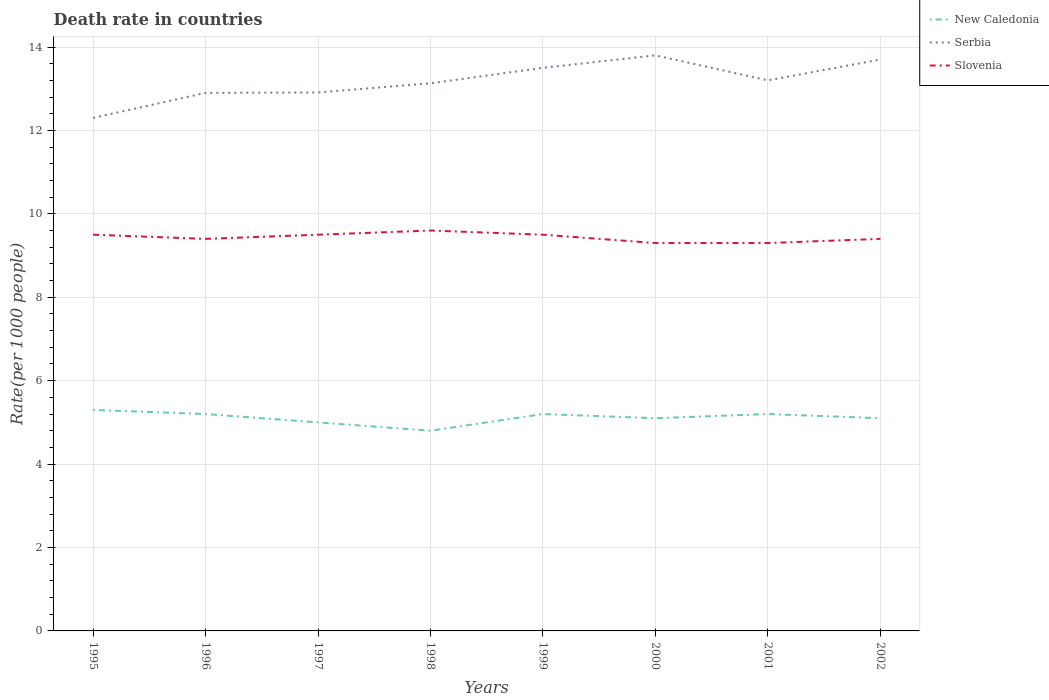How many different coloured lines are there?
Keep it short and to the point. 3. Does the line corresponding to Serbia intersect with the line corresponding to New Caledonia?
Provide a succinct answer. No. In which year was the death rate in New Caledonia maximum?
Your response must be concise. 1998. What is the total death rate in Serbia in the graph?
Give a very brief answer. 0.1. What is the difference between the highest and the second highest death rate in Slovenia?
Your response must be concise. 0.3. How many legend labels are there?
Give a very brief answer. 3. How are the legend labels stacked?
Your answer should be compact. Vertical. What is the title of the graph?
Your answer should be very brief. Death rate in countries. What is the label or title of the Y-axis?
Your response must be concise. Rate(per 1000 people). What is the Rate(per 1000 people) in Slovenia in 1995?
Keep it short and to the point. 9.5. What is the Rate(per 1000 people) in Serbia in 1996?
Offer a very short reply. 12.9. What is the Rate(per 1000 people) of Slovenia in 1996?
Give a very brief answer. 9.4. What is the Rate(per 1000 people) of New Caledonia in 1997?
Give a very brief answer. 5. What is the Rate(per 1000 people) of Serbia in 1997?
Ensure brevity in your answer.  12.91. What is the Rate(per 1000 people) in Slovenia in 1997?
Keep it short and to the point. 9.5. What is the Rate(per 1000 people) in New Caledonia in 1998?
Give a very brief answer. 4.8. What is the Rate(per 1000 people) in Serbia in 1998?
Your response must be concise. 13.13. What is the Rate(per 1000 people) of New Caledonia in 2000?
Offer a terse response. 5.1. What is the Rate(per 1000 people) of Slovenia in 2000?
Ensure brevity in your answer.  9.3. What is the Rate(per 1000 people) of Slovenia in 2001?
Offer a terse response. 9.3. What is the Rate(per 1000 people) in Serbia in 2002?
Your response must be concise. 13.7. Across all years, what is the maximum Rate(per 1000 people) of New Caledonia?
Your answer should be compact. 5.3. Across all years, what is the maximum Rate(per 1000 people) of Serbia?
Ensure brevity in your answer.  13.8. Across all years, what is the maximum Rate(per 1000 people) of Slovenia?
Keep it short and to the point. 9.6. Across all years, what is the minimum Rate(per 1000 people) in Serbia?
Your answer should be compact. 12.3. What is the total Rate(per 1000 people) of New Caledonia in the graph?
Offer a terse response. 40.9. What is the total Rate(per 1000 people) in Serbia in the graph?
Your answer should be very brief. 105.44. What is the total Rate(per 1000 people) of Slovenia in the graph?
Give a very brief answer. 75.5. What is the difference between the Rate(per 1000 people) of Slovenia in 1995 and that in 1996?
Your answer should be compact. 0.1. What is the difference between the Rate(per 1000 people) in Serbia in 1995 and that in 1997?
Give a very brief answer. -0.61. What is the difference between the Rate(per 1000 people) in Slovenia in 1995 and that in 1997?
Give a very brief answer. 0. What is the difference between the Rate(per 1000 people) of New Caledonia in 1995 and that in 1998?
Provide a short and direct response. 0.5. What is the difference between the Rate(per 1000 people) of Serbia in 1995 and that in 1998?
Provide a short and direct response. -0.83. What is the difference between the Rate(per 1000 people) of Slovenia in 1995 and that in 1998?
Give a very brief answer. -0.1. What is the difference between the Rate(per 1000 people) of New Caledonia in 1995 and that in 1999?
Provide a succinct answer. 0.1. What is the difference between the Rate(per 1000 people) in Serbia in 1995 and that in 1999?
Give a very brief answer. -1.2. What is the difference between the Rate(per 1000 people) in New Caledonia in 1995 and that in 2001?
Offer a terse response. 0.1. What is the difference between the Rate(per 1000 people) of New Caledonia in 1995 and that in 2002?
Your answer should be compact. 0.2. What is the difference between the Rate(per 1000 people) in Slovenia in 1995 and that in 2002?
Your response must be concise. 0.1. What is the difference between the Rate(per 1000 people) in Serbia in 1996 and that in 1997?
Your answer should be very brief. -0.01. What is the difference between the Rate(per 1000 people) of New Caledonia in 1996 and that in 1998?
Your response must be concise. 0.4. What is the difference between the Rate(per 1000 people) of Serbia in 1996 and that in 1998?
Ensure brevity in your answer.  -0.23. What is the difference between the Rate(per 1000 people) of Slovenia in 1996 and that in 1999?
Ensure brevity in your answer.  -0.1. What is the difference between the Rate(per 1000 people) of Serbia in 1996 and that in 2000?
Offer a very short reply. -0.9. What is the difference between the Rate(per 1000 people) in New Caledonia in 1996 and that in 2002?
Offer a terse response. 0.1. What is the difference between the Rate(per 1000 people) of Slovenia in 1996 and that in 2002?
Your answer should be compact. 0. What is the difference between the Rate(per 1000 people) of Serbia in 1997 and that in 1998?
Offer a very short reply. -0.22. What is the difference between the Rate(per 1000 people) of Slovenia in 1997 and that in 1998?
Offer a terse response. -0.1. What is the difference between the Rate(per 1000 people) of Serbia in 1997 and that in 1999?
Your answer should be very brief. -0.59. What is the difference between the Rate(per 1000 people) of Slovenia in 1997 and that in 1999?
Your answer should be very brief. 0. What is the difference between the Rate(per 1000 people) of New Caledonia in 1997 and that in 2000?
Provide a succinct answer. -0.1. What is the difference between the Rate(per 1000 people) in Serbia in 1997 and that in 2000?
Give a very brief answer. -0.89. What is the difference between the Rate(per 1000 people) of Slovenia in 1997 and that in 2000?
Keep it short and to the point. 0.2. What is the difference between the Rate(per 1000 people) in New Caledonia in 1997 and that in 2001?
Your response must be concise. -0.2. What is the difference between the Rate(per 1000 people) of Serbia in 1997 and that in 2001?
Ensure brevity in your answer.  -0.29. What is the difference between the Rate(per 1000 people) in Slovenia in 1997 and that in 2001?
Your answer should be compact. 0.2. What is the difference between the Rate(per 1000 people) in Serbia in 1997 and that in 2002?
Keep it short and to the point. -0.79. What is the difference between the Rate(per 1000 people) in Slovenia in 1997 and that in 2002?
Ensure brevity in your answer.  0.1. What is the difference between the Rate(per 1000 people) in New Caledonia in 1998 and that in 1999?
Provide a short and direct response. -0.4. What is the difference between the Rate(per 1000 people) in Serbia in 1998 and that in 1999?
Keep it short and to the point. -0.37. What is the difference between the Rate(per 1000 people) in New Caledonia in 1998 and that in 2000?
Your answer should be compact. -0.3. What is the difference between the Rate(per 1000 people) in Serbia in 1998 and that in 2000?
Give a very brief answer. -0.67. What is the difference between the Rate(per 1000 people) in Serbia in 1998 and that in 2001?
Your response must be concise. -0.07. What is the difference between the Rate(per 1000 people) in New Caledonia in 1998 and that in 2002?
Keep it short and to the point. -0.3. What is the difference between the Rate(per 1000 people) in Serbia in 1998 and that in 2002?
Ensure brevity in your answer.  -0.57. What is the difference between the Rate(per 1000 people) of Slovenia in 1998 and that in 2002?
Ensure brevity in your answer.  0.2. What is the difference between the Rate(per 1000 people) of New Caledonia in 1999 and that in 2000?
Make the answer very short. 0.1. What is the difference between the Rate(per 1000 people) in New Caledonia in 1999 and that in 2001?
Your response must be concise. 0. What is the difference between the Rate(per 1000 people) in New Caledonia in 2000 and that in 2001?
Ensure brevity in your answer.  -0.1. What is the difference between the Rate(per 1000 people) in Serbia in 2000 and that in 2001?
Provide a short and direct response. 0.6. What is the difference between the Rate(per 1000 people) of Slovenia in 2000 and that in 2002?
Provide a short and direct response. -0.1. What is the difference between the Rate(per 1000 people) in Serbia in 2001 and that in 2002?
Keep it short and to the point. -0.5. What is the difference between the Rate(per 1000 people) of Slovenia in 2001 and that in 2002?
Provide a short and direct response. -0.1. What is the difference between the Rate(per 1000 people) of New Caledonia in 1995 and the Rate(per 1000 people) of Serbia in 1996?
Offer a terse response. -7.6. What is the difference between the Rate(per 1000 people) of Serbia in 1995 and the Rate(per 1000 people) of Slovenia in 1996?
Ensure brevity in your answer.  2.9. What is the difference between the Rate(per 1000 people) of New Caledonia in 1995 and the Rate(per 1000 people) of Serbia in 1997?
Your response must be concise. -7.61. What is the difference between the Rate(per 1000 people) in Serbia in 1995 and the Rate(per 1000 people) in Slovenia in 1997?
Give a very brief answer. 2.8. What is the difference between the Rate(per 1000 people) of New Caledonia in 1995 and the Rate(per 1000 people) of Serbia in 1998?
Ensure brevity in your answer.  -7.83. What is the difference between the Rate(per 1000 people) of New Caledonia in 1995 and the Rate(per 1000 people) of Slovenia in 1998?
Provide a succinct answer. -4.3. What is the difference between the Rate(per 1000 people) in New Caledonia in 1995 and the Rate(per 1000 people) in Serbia in 1999?
Ensure brevity in your answer.  -8.2. What is the difference between the Rate(per 1000 people) in New Caledonia in 1995 and the Rate(per 1000 people) in Slovenia in 1999?
Ensure brevity in your answer.  -4.2. What is the difference between the Rate(per 1000 people) of Serbia in 1995 and the Rate(per 1000 people) of Slovenia in 1999?
Give a very brief answer. 2.8. What is the difference between the Rate(per 1000 people) of New Caledonia in 1995 and the Rate(per 1000 people) of Serbia in 2000?
Offer a very short reply. -8.5. What is the difference between the Rate(per 1000 people) in Serbia in 1995 and the Rate(per 1000 people) in Slovenia in 2000?
Your answer should be compact. 3. What is the difference between the Rate(per 1000 people) of New Caledonia in 1995 and the Rate(per 1000 people) of Serbia in 2001?
Your answer should be compact. -7.9. What is the difference between the Rate(per 1000 people) of Serbia in 1995 and the Rate(per 1000 people) of Slovenia in 2001?
Your response must be concise. 3. What is the difference between the Rate(per 1000 people) in New Caledonia in 1995 and the Rate(per 1000 people) in Serbia in 2002?
Offer a terse response. -8.4. What is the difference between the Rate(per 1000 people) in New Caledonia in 1995 and the Rate(per 1000 people) in Slovenia in 2002?
Your response must be concise. -4.1. What is the difference between the Rate(per 1000 people) of New Caledonia in 1996 and the Rate(per 1000 people) of Serbia in 1997?
Your answer should be very brief. -7.71. What is the difference between the Rate(per 1000 people) in New Caledonia in 1996 and the Rate(per 1000 people) in Slovenia in 1997?
Keep it short and to the point. -4.3. What is the difference between the Rate(per 1000 people) in New Caledonia in 1996 and the Rate(per 1000 people) in Serbia in 1998?
Your response must be concise. -7.93. What is the difference between the Rate(per 1000 people) in New Caledonia in 1996 and the Rate(per 1000 people) in Slovenia in 1998?
Ensure brevity in your answer.  -4.4. What is the difference between the Rate(per 1000 people) of Serbia in 1996 and the Rate(per 1000 people) of Slovenia in 1999?
Provide a succinct answer. 3.4. What is the difference between the Rate(per 1000 people) of New Caledonia in 1996 and the Rate(per 1000 people) of Serbia in 2001?
Offer a very short reply. -8. What is the difference between the Rate(per 1000 people) in Serbia in 1996 and the Rate(per 1000 people) in Slovenia in 2001?
Offer a terse response. 3.6. What is the difference between the Rate(per 1000 people) in New Caledonia in 1996 and the Rate(per 1000 people) in Serbia in 2002?
Make the answer very short. -8.5. What is the difference between the Rate(per 1000 people) of Serbia in 1996 and the Rate(per 1000 people) of Slovenia in 2002?
Give a very brief answer. 3.5. What is the difference between the Rate(per 1000 people) of New Caledonia in 1997 and the Rate(per 1000 people) of Serbia in 1998?
Offer a very short reply. -8.13. What is the difference between the Rate(per 1000 people) in Serbia in 1997 and the Rate(per 1000 people) in Slovenia in 1998?
Your answer should be compact. 3.31. What is the difference between the Rate(per 1000 people) of New Caledonia in 1997 and the Rate(per 1000 people) of Serbia in 1999?
Make the answer very short. -8.5. What is the difference between the Rate(per 1000 people) of New Caledonia in 1997 and the Rate(per 1000 people) of Slovenia in 1999?
Make the answer very short. -4.5. What is the difference between the Rate(per 1000 people) of Serbia in 1997 and the Rate(per 1000 people) of Slovenia in 1999?
Your answer should be very brief. 3.41. What is the difference between the Rate(per 1000 people) in New Caledonia in 1997 and the Rate(per 1000 people) in Serbia in 2000?
Provide a short and direct response. -8.8. What is the difference between the Rate(per 1000 people) in Serbia in 1997 and the Rate(per 1000 people) in Slovenia in 2000?
Keep it short and to the point. 3.61. What is the difference between the Rate(per 1000 people) of New Caledonia in 1997 and the Rate(per 1000 people) of Serbia in 2001?
Keep it short and to the point. -8.2. What is the difference between the Rate(per 1000 people) in Serbia in 1997 and the Rate(per 1000 people) in Slovenia in 2001?
Ensure brevity in your answer.  3.61. What is the difference between the Rate(per 1000 people) of New Caledonia in 1997 and the Rate(per 1000 people) of Serbia in 2002?
Keep it short and to the point. -8.7. What is the difference between the Rate(per 1000 people) of New Caledonia in 1997 and the Rate(per 1000 people) of Slovenia in 2002?
Offer a very short reply. -4.4. What is the difference between the Rate(per 1000 people) in Serbia in 1997 and the Rate(per 1000 people) in Slovenia in 2002?
Keep it short and to the point. 3.51. What is the difference between the Rate(per 1000 people) in New Caledonia in 1998 and the Rate(per 1000 people) in Slovenia in 1999?
Ensure brevity in your answer.  -4.7. What is the difference between the Rate(per 1000 people) in Serbia in 1998 and the Rate(per 1000 people) in Slovenia in 1999?
Provide a short and direct response. 3.63. What is the difference between the Rate(per 1000 people) of New Caledonia in 1998 and the Rate(per 1000 people) of Serbia in 2000?
Provide a succinct answer. -9. What is the difference between the Rate(per 1000 people) in New Caledonia in 1998 and the Rate(per 1000 people) in Slovenia in 2000?
Give a very brief answer. -4.5. What is the difference between the Rate(per 1000 people) of Serbia in 1998 and the Rate(per 1000 people) of Slovenia in 2000?
Ensure brevity in your answer.  3.83. What is the difference between the Rate(per 1000 people) in Serbia in 1998 and the Rate(per 1000 people) in Slovenia in 2001?
Ensure brevity in your answer.  3.83. What is the difference between the Rate(per 1000 people) in New Caledonia in 1998 and the Rate(per 1000 people) in Serbia in 2002?
Make the answer very short. -8.9. What is the difference between the Rate(per 1000 people) of Serbia in 1998 and the Rate(per 1000 people) of Slovenia in 2002?
Offer a terse response. 3.73. What is the difference between the Rate(per 1000 people) in New Caledonia in 1999 and the Rate(per 1000 people) in Slovenia in 2000?
Your answer should be very brief. -4.1. What is the difference between the Rate(per 1000 people) in Serbia in 1999 and the Rate(per 1000 people) in Slovenia in 2002?
Provide a succinct answer. 4.1. What is the difference between the Rate(per 1000 people) of Serbia in 2000 and the Rate(per 1000 people) of Slovenia in 2001?
Make the answer very short. 4.5. What is the difference between the Rate(per 1000 people) of New Caledonia in 2000 and the Rate(per 1000 people) of Serbia in 2002?
Make the answer very short. -8.6. What is the difference between the Rate(per 1000 people) of New Caledonia in 2000 and the Rate(per 1000 people) of Slovenia in 2002?
Offer a very short reply. -4.3. What is the difference between the Rate(per 1000 people) of New Caledonia in 2001 and the Rate(per 1000 people) of Serbia in 2002?
Keep it short and to the point. -8.5. What is the average Rate(per 1000 people) in New Caledonia per year?
Keep it short and to the point. 5.11. What is the average Rate(per 1000 people) in Serbia per year?
Keep it short and to the point. 13.18. What is the average Rate(per 1000 people) in Slovenia per year?
Provide a short and direct response. 9.44. In the year 1995, what is the difference between the Rate(per 1000 people) in New Caledonia and Rate(per 1000 people) in Slovenia?
Keep it short and to the point. -4.2. In the year 1995, what is the difference between the Rate(per 1000 people) of Serbia and Rate(per 1000 people) of Slovenia?
Your answer should be very brief. 2.8. In the year 1996, what is the difference between the Rate(per 1000 people) in New Caledonia and Rate(per 1000 people) in Serbia?
Provide a short and direct response. -7.7. In the year 1996, what is the difference between the Rate(per 1000 people) of Serbia and Rate(per 1000 people) of Slovenia?
Make the answer very short. 3.5. In the year 1997, what is the difference between the Rate(per 1000 people) in New Caledonia and Rate(per 1000 people) in Serbia?
Offer a very short reply. -7.91. In the year 1997, what is the difference between the Rate(per 1000 people) in New Caledonia and Rate(per 1000 people) in Slovenia?
Your answer should be compact. -4.5. In the year 1997, what is the difference between the Rate(per 1000 people) in Serbia and Rate(per 1000 people) in Slovenia?
Keep it short and to the point. 3.41. In the year 1998, what is the difference between the Rate(per 1000 people) in New Caledonia and Rate(per 1000 people) in Serbia?
Keep it short and to the point. -8.33. In the year 1998, what is the difference between the Rate(per 1000 people) in Serbia and Rate(per 1000 people) in Slovenia?
Your answer should be very brief. 3.53. In the year 1999, what is the difference between the Rate(per 1000 people) in New Caledonia and Rate(per 1000 people) in Slovenia?
Provide a succinct answer. -4.3. In the year 2000, what is the difference between the Rate(per 1000 people) of Serbia and Rate(per 1000 people) of Slovenia?
Offer a terse response. 4.5. In the year 2001, what is the difference between the Rate(per 1000 people) of New Caledonia and Rate(per 1000 people) of Slovenia?
Ensure brevity in your answer.  -4.1. In the year 2001, what is the difference between the Rate(per 1000 people) in Serbia and Rate(per 1000 people) in Slovenia?
Make the answer very short. 3.9. What is the ratio of the Rate(per 1000 people) in New Caledonia in 1995 to that in 1996?
Offer a very short reply. 1.02. What is the ratio of the Rate(per 1000 people) in Serbia in 1995 to that in 1996?
Offer a very short reply. 0.95. What is the ratio of the Rate(per 1000 people) of Slovenia in 1995 to that in 1996?
Your answer should be compact. 1.01. What is the ratio of the Rate(per 1000 people) of New Caledonia in 1995 to that in 1997?
Provide a short and direct response. 1.06. What is the ratio of the Rate(per 1000 people) in Serbia in 1995 to that in 1997?
Ensure brevity in your answer.  0.95. What is the ratio of the Rate(per 1000 people) of New Caledonia in 1995 to that in 1998?
Your answer should be very brief. 1.1. What is the ratio of the Rate(per 1000 people) in Serbia in 1995 to that in 1998?
Offer a terse response. 0.94. What is the ratio of the Rate(per 1000 people) of Slovenia in 1995 to that in 1998?
Ensure brevity in your answer.  0.99. What is the ratio of the Rate(per 1000 people) of New Caledonia in 1995 to that in 1999?
Give a very brief answer. 1.02. What is the ratio of the Rate(per 1000 people) of Serbia in 1995 to that in 1999?
Your answer should be compact. 0.91. What is the ratio of the Rate(per 1000 people) in Slovenia in 1995 to that in 1999?
Offer a very short reply. 1. What is the ratio of the Rate(per 1000 people) in New Caledonia in 1995 to that in 2000?
Give a very brief answer. 1.04. What is the ratio of the Rate(per 1000 people) of Serbia in 1995 to that in 2000?
Offer a very short reply. 0.89. What is the ratio of the Rate(per 1000 people) in Slovenia in 1995 to that in 2000?
Ensure brevity in your answer.  1.02. What is the ratio of the Rate(per 1000 people) of New Caledonia in 1995 to that in 2001?
Your answer should be compact. 1.02. What is the ratio of the Rate(per 1000 people) in Serbia in 1995 to that in 2001?
Your response must be concise. 0.93. What is the ratio of the Rate(per 1000 people) of Slovenia in 1995 to that in 2001?
Offer a very short reply. 1.02. What is the ratio of the Rate(per 1000 people) in New Caledonia in 1995 to that in 2002?
Your answer should be compact. 1.04. What is the ratio of the Rate(per 1000 people) of Serbia in 1995 to that in 2002?
Provide a succinct answer. 0.9. What is the ratio of the Rate(per 1000 people) in Slovenia in 1995 to that in 2002?
Offer a terse response. 1.01. What is the ratio of the Rate(per 1000 people) of Serbia in 1996 to that in 1997?
Keep it short and to the point. 1. What is the ratio of the Rate(per 1000 people) of New Caledonia in 1996 to that in 1998?
Provide a short and direct response. 1.08. What is the ratio of the Rate(per 1000 people) of Serbia in 1996 to that in 1998?
Provide a succinct answer. 0.98. What is the ratio of the Rate(per 1000 people) of Slovenia in 1996 to that in 1998?
Ensure brevity in your answer.  0.98. What is the ratio of the Rate(per 1000 people) of Serbia in 1996 to that in 1999?
Your answer should be very brief. 0.96. What is the ratio of the Rate(per 1000 people) of Slovenia in 1996 to that in 1999?
Keep it short and to the point. 0.99. What is the ratio of the Rate(per 1000 people) in New Caledonia in 1996 to that in 2000?
Provide a succinct answer. 1.02. What is the ratio of the Rate(per 1000 people) of Serbia in 1996 to that in 2000?
Offer a very short reply. 0.93. What is the ratio of the Rate(per 1000 people) of Slovenia in 1996 to that in 2000?
Your response must be concise. 1.01. What is the ratio of the Rate(per 1000 people) of Serbia in 1996 to that in 2001?
Your answer should be very brief. 0.98. What is the ratio of the Rate(per 1000 people) in Slovenia in 1996 to that in 2001?
Offer a very short reply. 1.01. What is the ratio of the Rate(per 1000 people) in New Caledonia in 1996 to that in 2002?
Keep it short and to the point. 1.02. What is the ratio of the Rate(per 1000 people) of Serbia in 1996 to that in 2002?
Give a very brief answer. 0.94. What is the ratio of the Rate(per 1000 people) in New Caledonia in 1997 to that in 1998?
Give a very brief answer. 1.04. What is the ratio of the Rate(per 1000 people) of Serbia in 1997 to that in 1998?
Your response must be concise. 0.98. What is the ratio of the Rate(per 1000 people) of Slovenia in 1997 to that in 1998?
Offer a very short reply. 0.99. What is the ratio of the Rate(per 1000 people) in New Caledonia in 1997 to that in 1999?
Provide a short and direct response. 0.96. What is the ratio of the Rate(per 1000 people) in Serbia in 1997 to that in 1999?
Provide a short and direct response. 0.96. What is the ratio of the Rate(per 1000 people) in New Caledonia in 1997 to that in 2000?
Ensure brevity in your answer.  0.98. What is the ratio of the Rate(per 1000 people) of Serbia in 1997 to that in 2000?
Offer a terse response. 0.94. What is the ratio of the Rate(per 1000 people) in Slovenia in 1997 to that in 2000?
Give a very brief answer. 1.02. What is the ratio of the Rate(per 1000 people) in New Caledonia in 1997 to that in 2001?
Make the answer very short. 0.96. What is the ratio of the Rate(per 1000 people) of Serbia in 1997 to that in 2001?
Your answer should be very brief. 0.98. What is the ratio of the Rate(per 1000 people) of Slovenia in 1997 to that in 2001?
Provide a succinct answer. 1.02. What is the ratio of the Rate(per 1000 people) of New Caledonia in 1997 to that in 2002?
Give a very brief answer. 0.98. What is the ratio of the Rate(per 1000 people) in Serbia in 1997 to that in 2002?
Offer a terse response. 0.94. What is the ratio of the Rate(per 1000 people) of Slovenia in 1997 to that in 2002?
Your answer should be compact. 1.01. What is the ratio of the Rate(per 1000 people) of Serbia in 1998 to that in 1999?
Ensure brevity in your answer.  0.97. What is the ratio of the Rate(per 1000 people) in Slovenia in 1998 to that in 1999?
Your answer should be compact. 1.01. What is the ratio of the Rate(per 1000 people) in Serbia in 1998 to that in 2000?
Make the answer very short. 0.95. What is the ratio of the Rate(per 1000 people) of Slovenia in 1998 to that in 2000?
Keep it short and to the point. 1.03. What is the ratio of the Rate(per 1000 people) of New Caledonia in 1998 to that in 2001?
Make the answer very short. 0.92. What is the ratio of the Rate(per 1000 people) in Slovenia in 1998 to that in 2001?
Your response must be concise. 1.03. What is the ratio of the Rate(per 1000 people) of New Caledonia in 1998 to that in 2002?
Your answer should be very brief. 0.94. What is the ratio of the Rate(per 1000 people) of Serbia in 1998 to that in 2002?
Provide a succinct answer. 0.96. What is the ratio of the Rate(per 1000 people) of Slovenia in 1998 to that in 2002?
Provide a short and direct response. 1.02. What is the ratio of the Rate(per 1000 people) of New Caledonia in 1999 to that in 2000?
Keep it short and to the point. 1.02. What is the ratio of the Rate(per 1000 people) in Serbia in 1999 to that in 2000?
Your response must be concise. 0.98. What is the ratio of the Rate(per 1000 people) in Slovenia in 1999 to that in 2000?
Provide a short and direct response. 1.02. What is the ratio of the Rate(per 1000 people) of Serbia in 1999 to that in 2001?
Give a very brief answer. 1.02. What is the ratio of the Rate(per 1000 people) in Slovenia in 1999 to that in 2001?
Provide a succinct answer. 1.02. What is the ratio of the Rate(per 1000 people) in New Caledonia in 1999 to that in 2002?
Give a very brief answer. 1.02. What is the ratio of the Rate(per 1000 people) in Serbia in 1999 to that in 2002?
Your answer should be very brief. 0.99. What is the ratio of the Rate(per 1000 people) in Slovenia in 1999 to that in 2002?
Provide a succinct answer. 1.01. What is the ratio of the Rate(per 1000 people) in New Caledonia in 2000 to that in 2001?
Your response must be concise. 0.98. What is the ratio of the Rate(per 1000 people) in Serbia in 2000 to that in 2001?
Your answer should be very brief. 1.05. What is the ratio of the Rate(per 1000 people) in Slovenia in 2000 to that in 2001?
Provide a short and direct response. 1. What is the ratio of the Rate(per 1000 people) of Serbia in 2000 to that in 2002?
Provide a succinct answer. 1.01. What is the ratio of the Rate(per 1000 people) of Slovenia in 2000 to that in 2002?
Offer a very short reply. 0.99. What is the ratio of the Rate(per 1000 people) in New Caledonia in 2001 to that in 2002?
Ensure brevity in your answer.  1.02. What is the ratio of the Rate(per 1000 people) in Serbia in 2001 to that in 2002?
Give a very brief answer. 0.96. What is the difference between the highest and the second highest Rate(per 1000 people) in Serbia?
Ensure brevity in your answer.  0.1. What is the difference between the highest and the second highest Rate(per 1000 people) of Slovenia?
Make the answer very short. 0.1. What is the difference between the highest and the lowest Rate(per 1000 people) of Slovenia?
Give a very brief answer. 0.3. 